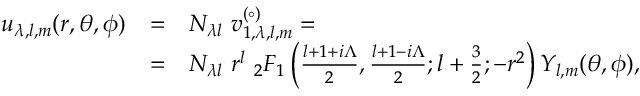<formula> <loc_0><loc_0><loc_500><loc_500>\begin{array} { r c l } { { u _ { \lambda , l , m } ( r , \theta , \phi ) } } & { = } & { { N _ { \lambda l } \ v _ { 1 , \lambda , l , m } ^ { ( \circ ) } = } } & { = } & { { N _ { \lambda l } \ r ^ { l } \ _ { 2 } F _ { 1 } \left ( { \frac { l + 1 + i \Lambda } { 2 } } , { \frac { l + 1 - i \Lambda } { 2 } } ; l + { \frac { 3 } { 2 } } ; - r ^ { 2 } \right ) Y _ { l , m } ( \theta , \phi ) , } } \end{array}</formula> 